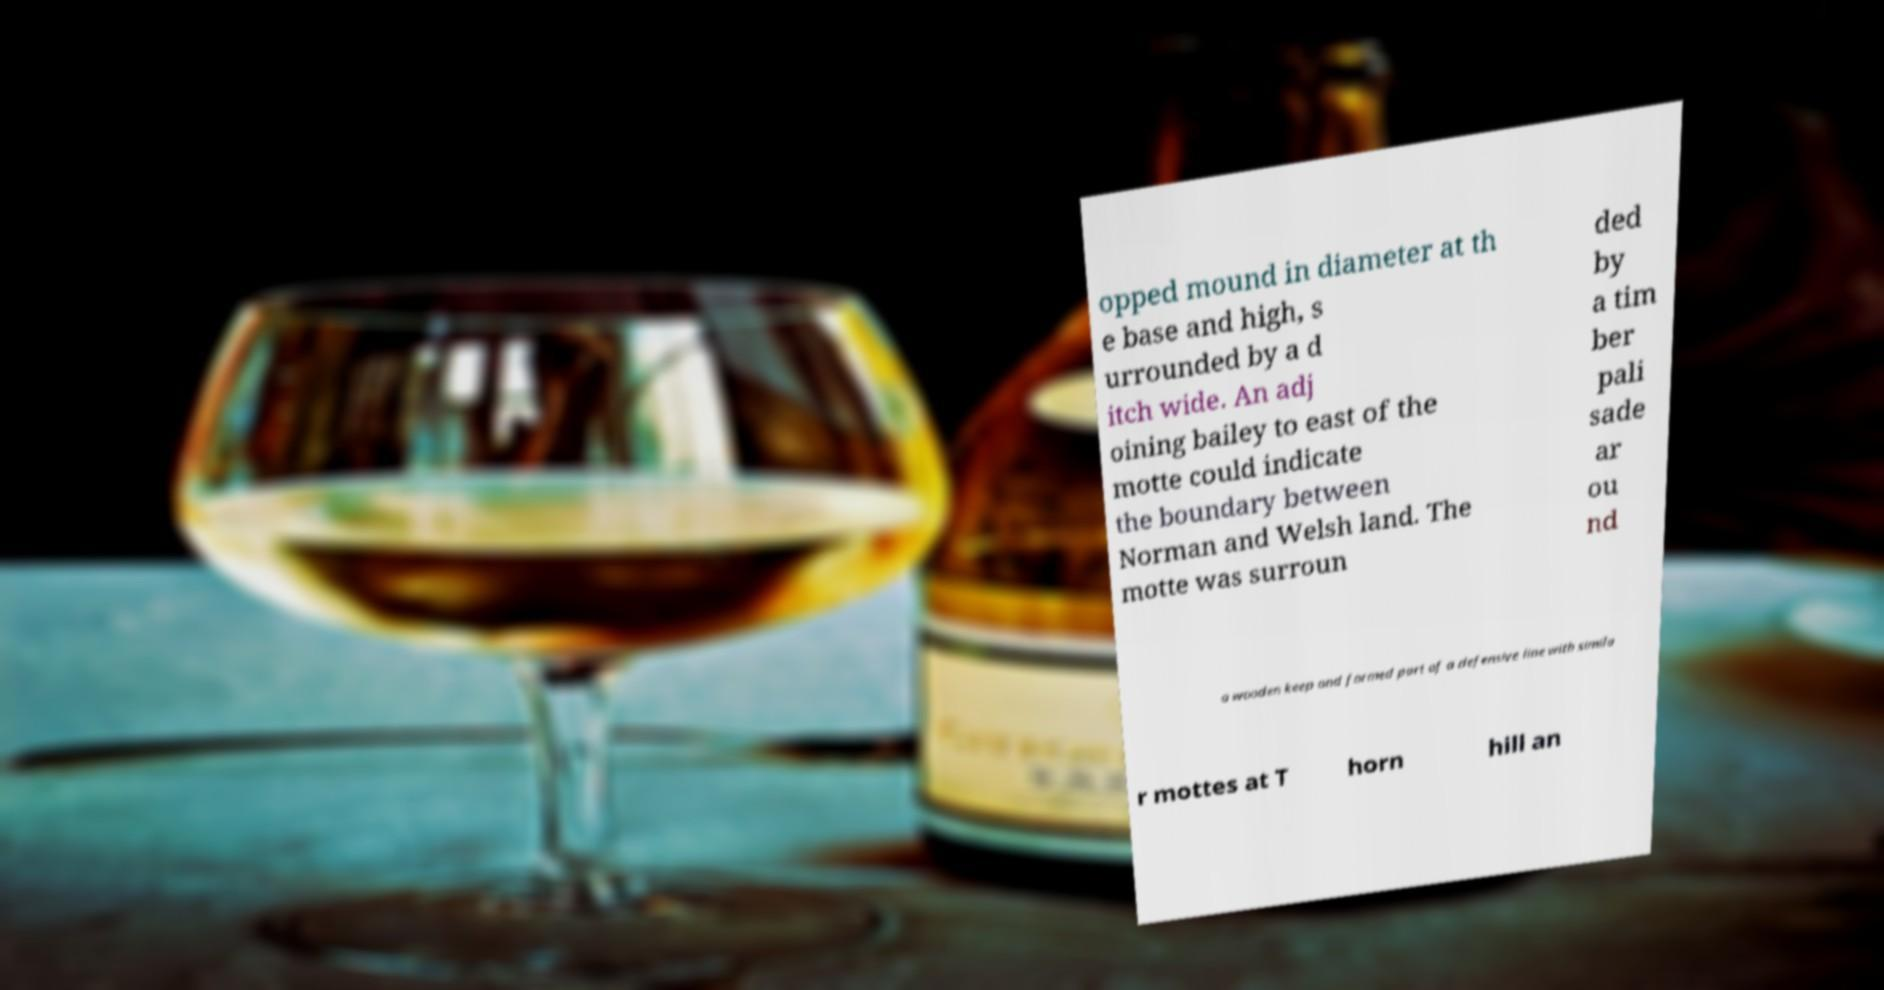Could you extract and type out the text from this image? opped mound in diameter at th e base and high, s urrounded by a d itch wide. An adj oining bailey to east of the motte could indicate the boundary between Norman and Welsh land. The motte was surroun ded by a tim ber pali sade ar ou nd a wooden keep and formed part of a defensive line with simila r mottes at T horn hill an 